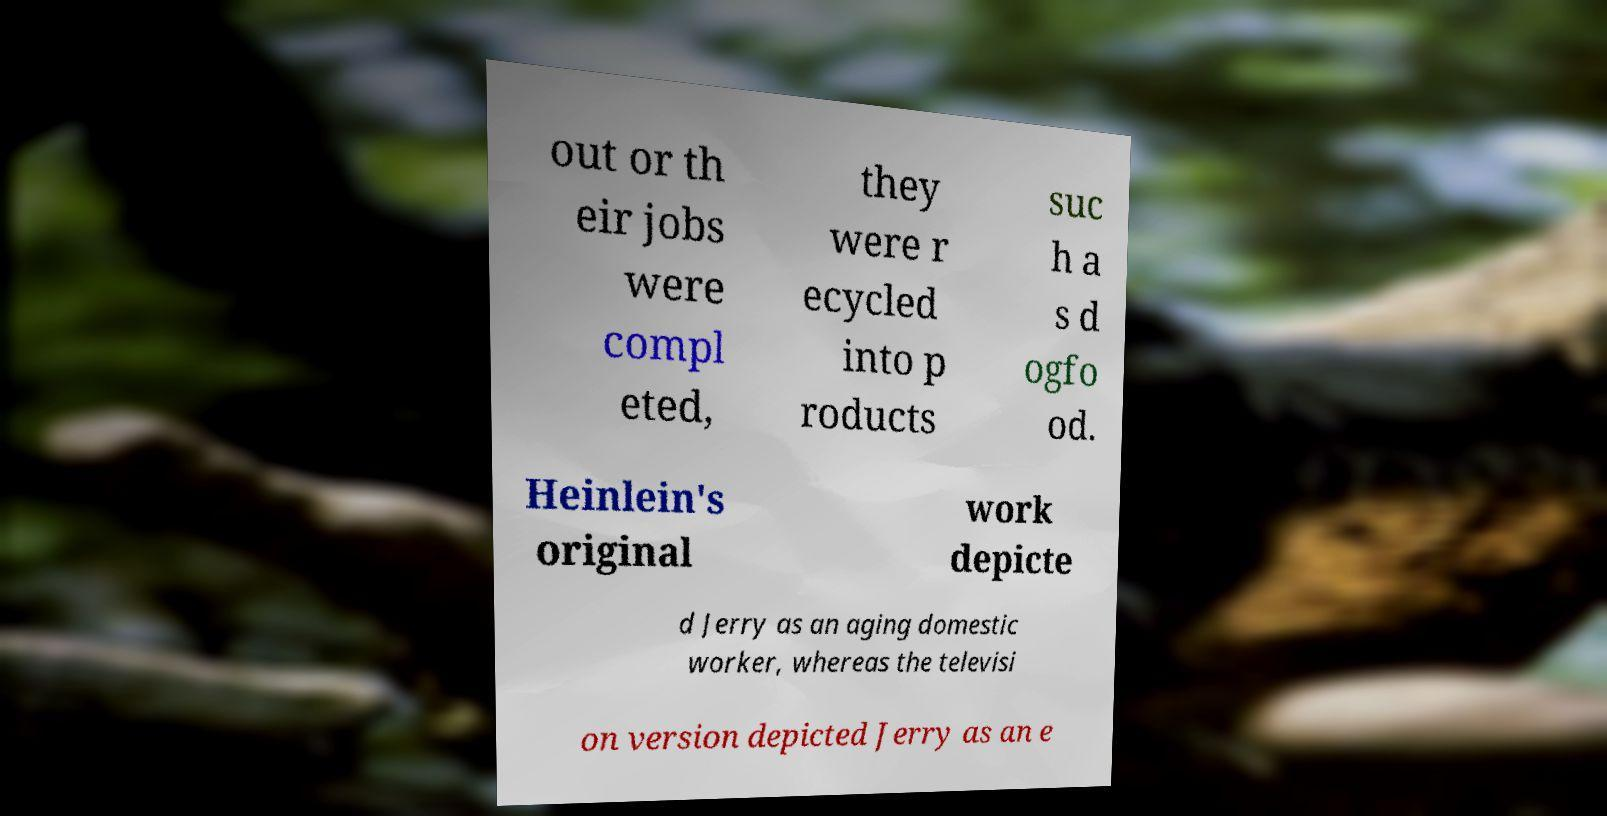For documentation purposes, I need the text within this image transcribed. Could you provide that? out or th eir jobs were compl eted, they were r ecycled into p roducts suc h a s d ogfo od. Heinlein's original work depicte d Jerry as an aging domestic worker, whereas the televisi on version depicted Jerry as an e 